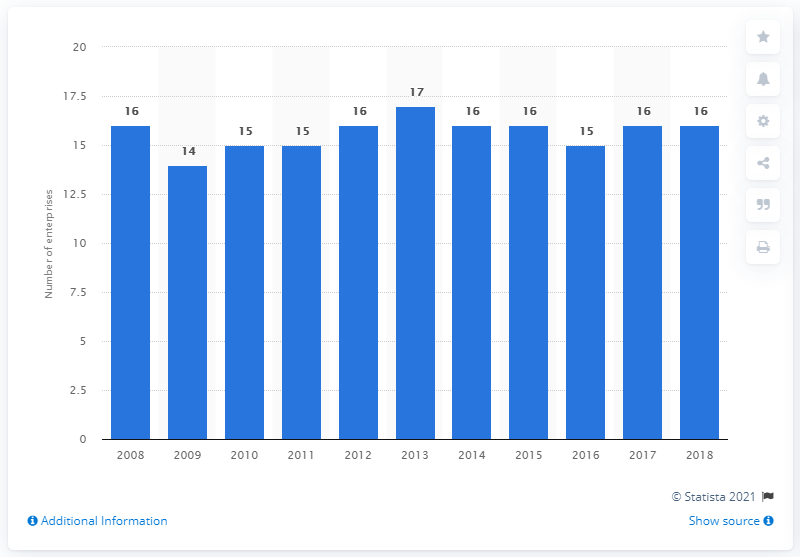Outline some significant characteristics in this image. There were 16 enterprises involved in the manufacturing of soft drinks in Cyprus in 2018. 